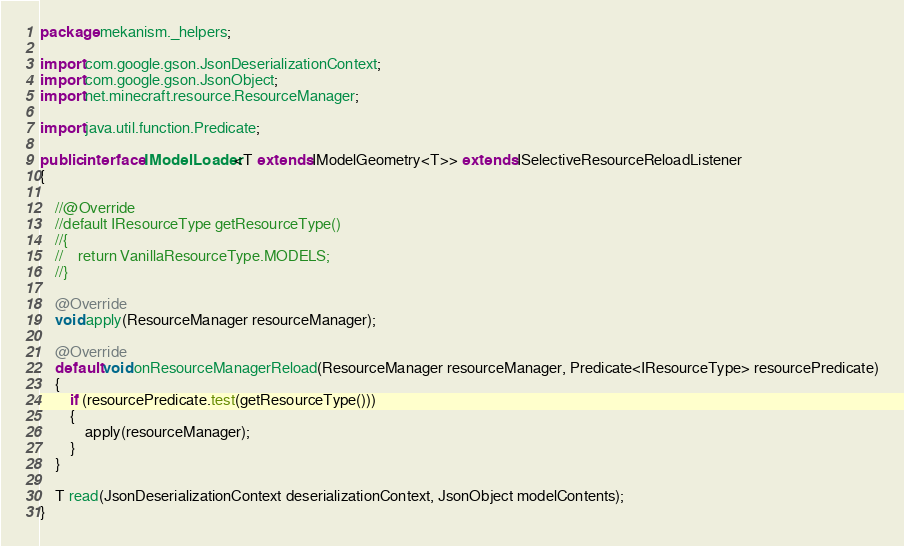Convert code to text. <code><loc_0><loc_0><loc_500><loc_500><_Java_>package mekanism._helpers;

import com.google.gson.JsonDeserializationContext;
import com.google.gson.JsonObject;
import net.minecraft.resource.ResourceManager;

import java.util.function.Predicate;

public interface IModelLoader<T extends IModelGeometry<T>> extends ISelectiveResourceReloadListener
{

    //@Override
    //default IResourceType getResourceType()
    //{
    //    return VanillaResourceType.MODELS;
    //}

    @Override
    void apply(ResourceManager resourceManager);

    @Override
    default void onResourceManagerReload(ResourceManager resourceManager, Predicate<IResourceType> resourcePredicate)
    {
        if (resourcePredicate.test(getResourceType()))
        {
            apply(resourceManager);
        }
    }

    T read(JsonDeserializationContext deserializationContext, JsonObject modelContents);
}
</code> 